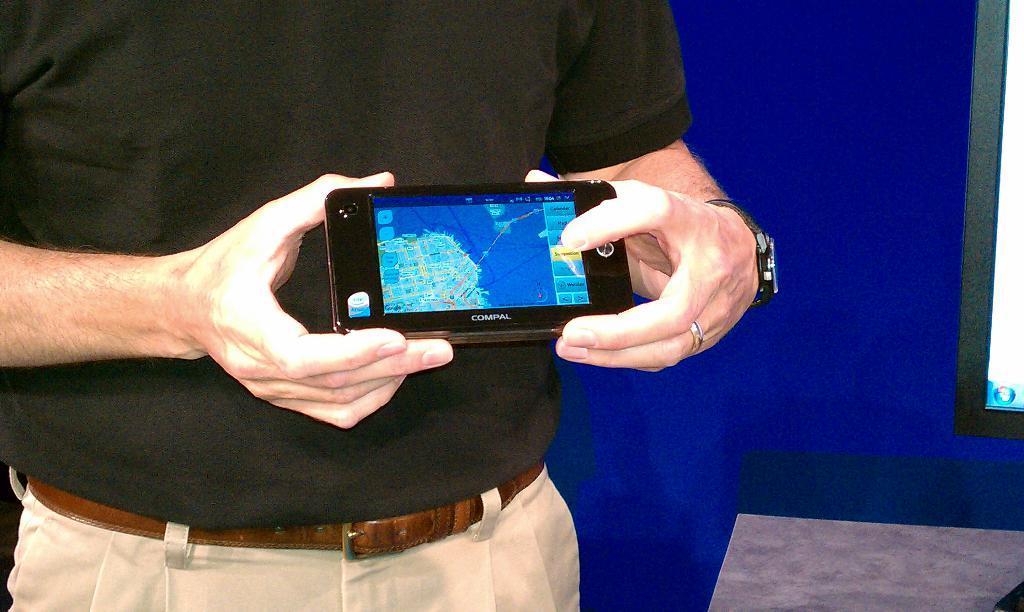Can you describe this image briefly? In the foreground I can see a person is holding a mobile in hand is standing on the floor. In the background I can see a wall. This image is taken in a hall. 